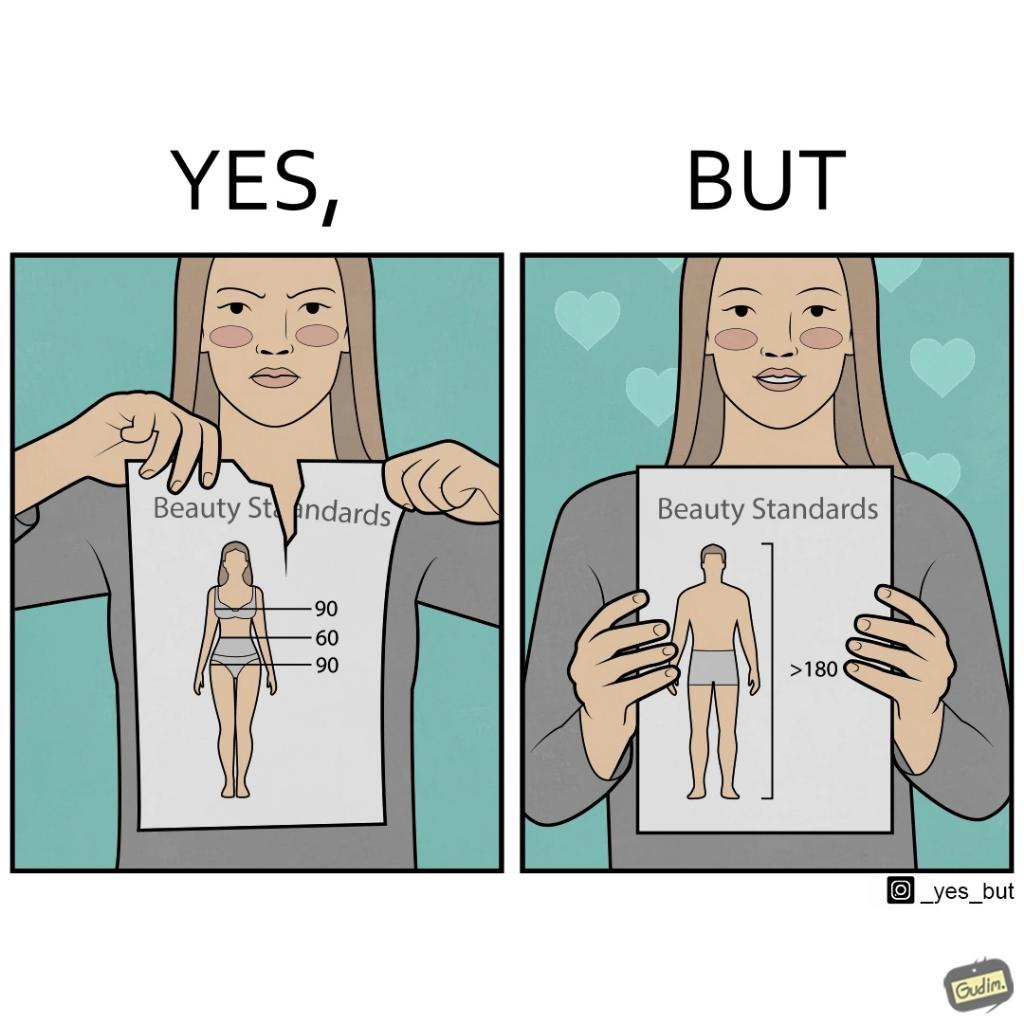What does this image depict? The image is ironic because the woman that is angry about having constraints set on the body parts of a woman to be considered beautiful is the same person who is happily presenting contraints on the height of a man to be considered beautiful. 